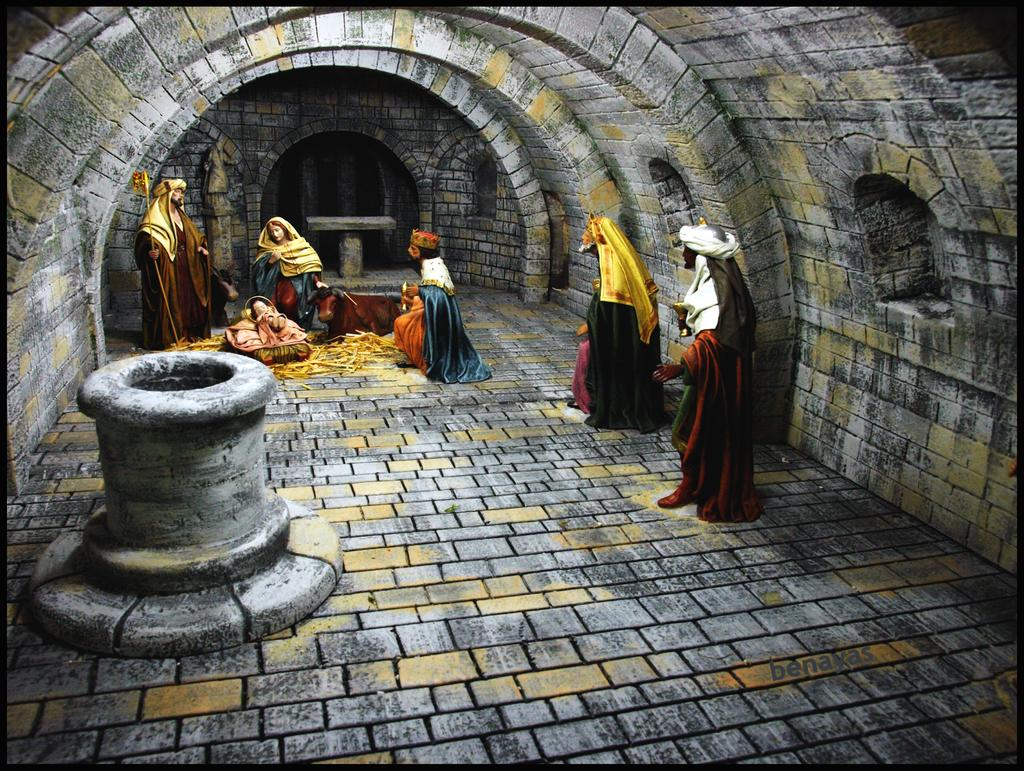What type of objects are present in the image? There are statues in the image. What type of structure can be seen in the image? There is a wall in the image. What type of guide is present in the image? There is no guide present in the image; it only features statues and a wall. What type of corn can be seen growing near the statues in the image? There is no corn present in the image; it only features statues and a wall. 